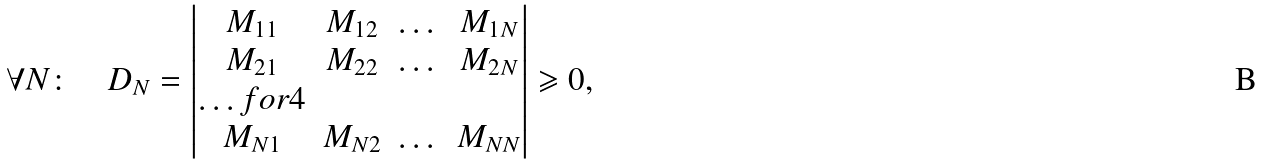<formula> <loc_0><loc_0><loc_500><loc_500>\forall N \colon \quad D _ { N } = \begin{vmatrix} M _ { 1 1 } & M _ { 1 2 } & \dots & M _ { 1 N } \\ M _ { 2 1 } & M _ { 2 2 } & \dots & M _ { 2 N } \\ \hdots f o r { 4 } \\ M _ { N 1 } & M _ { N 2 } & \dots & M _ { N N } \end{vmatrix} \geqslant 0 ,</formula> 